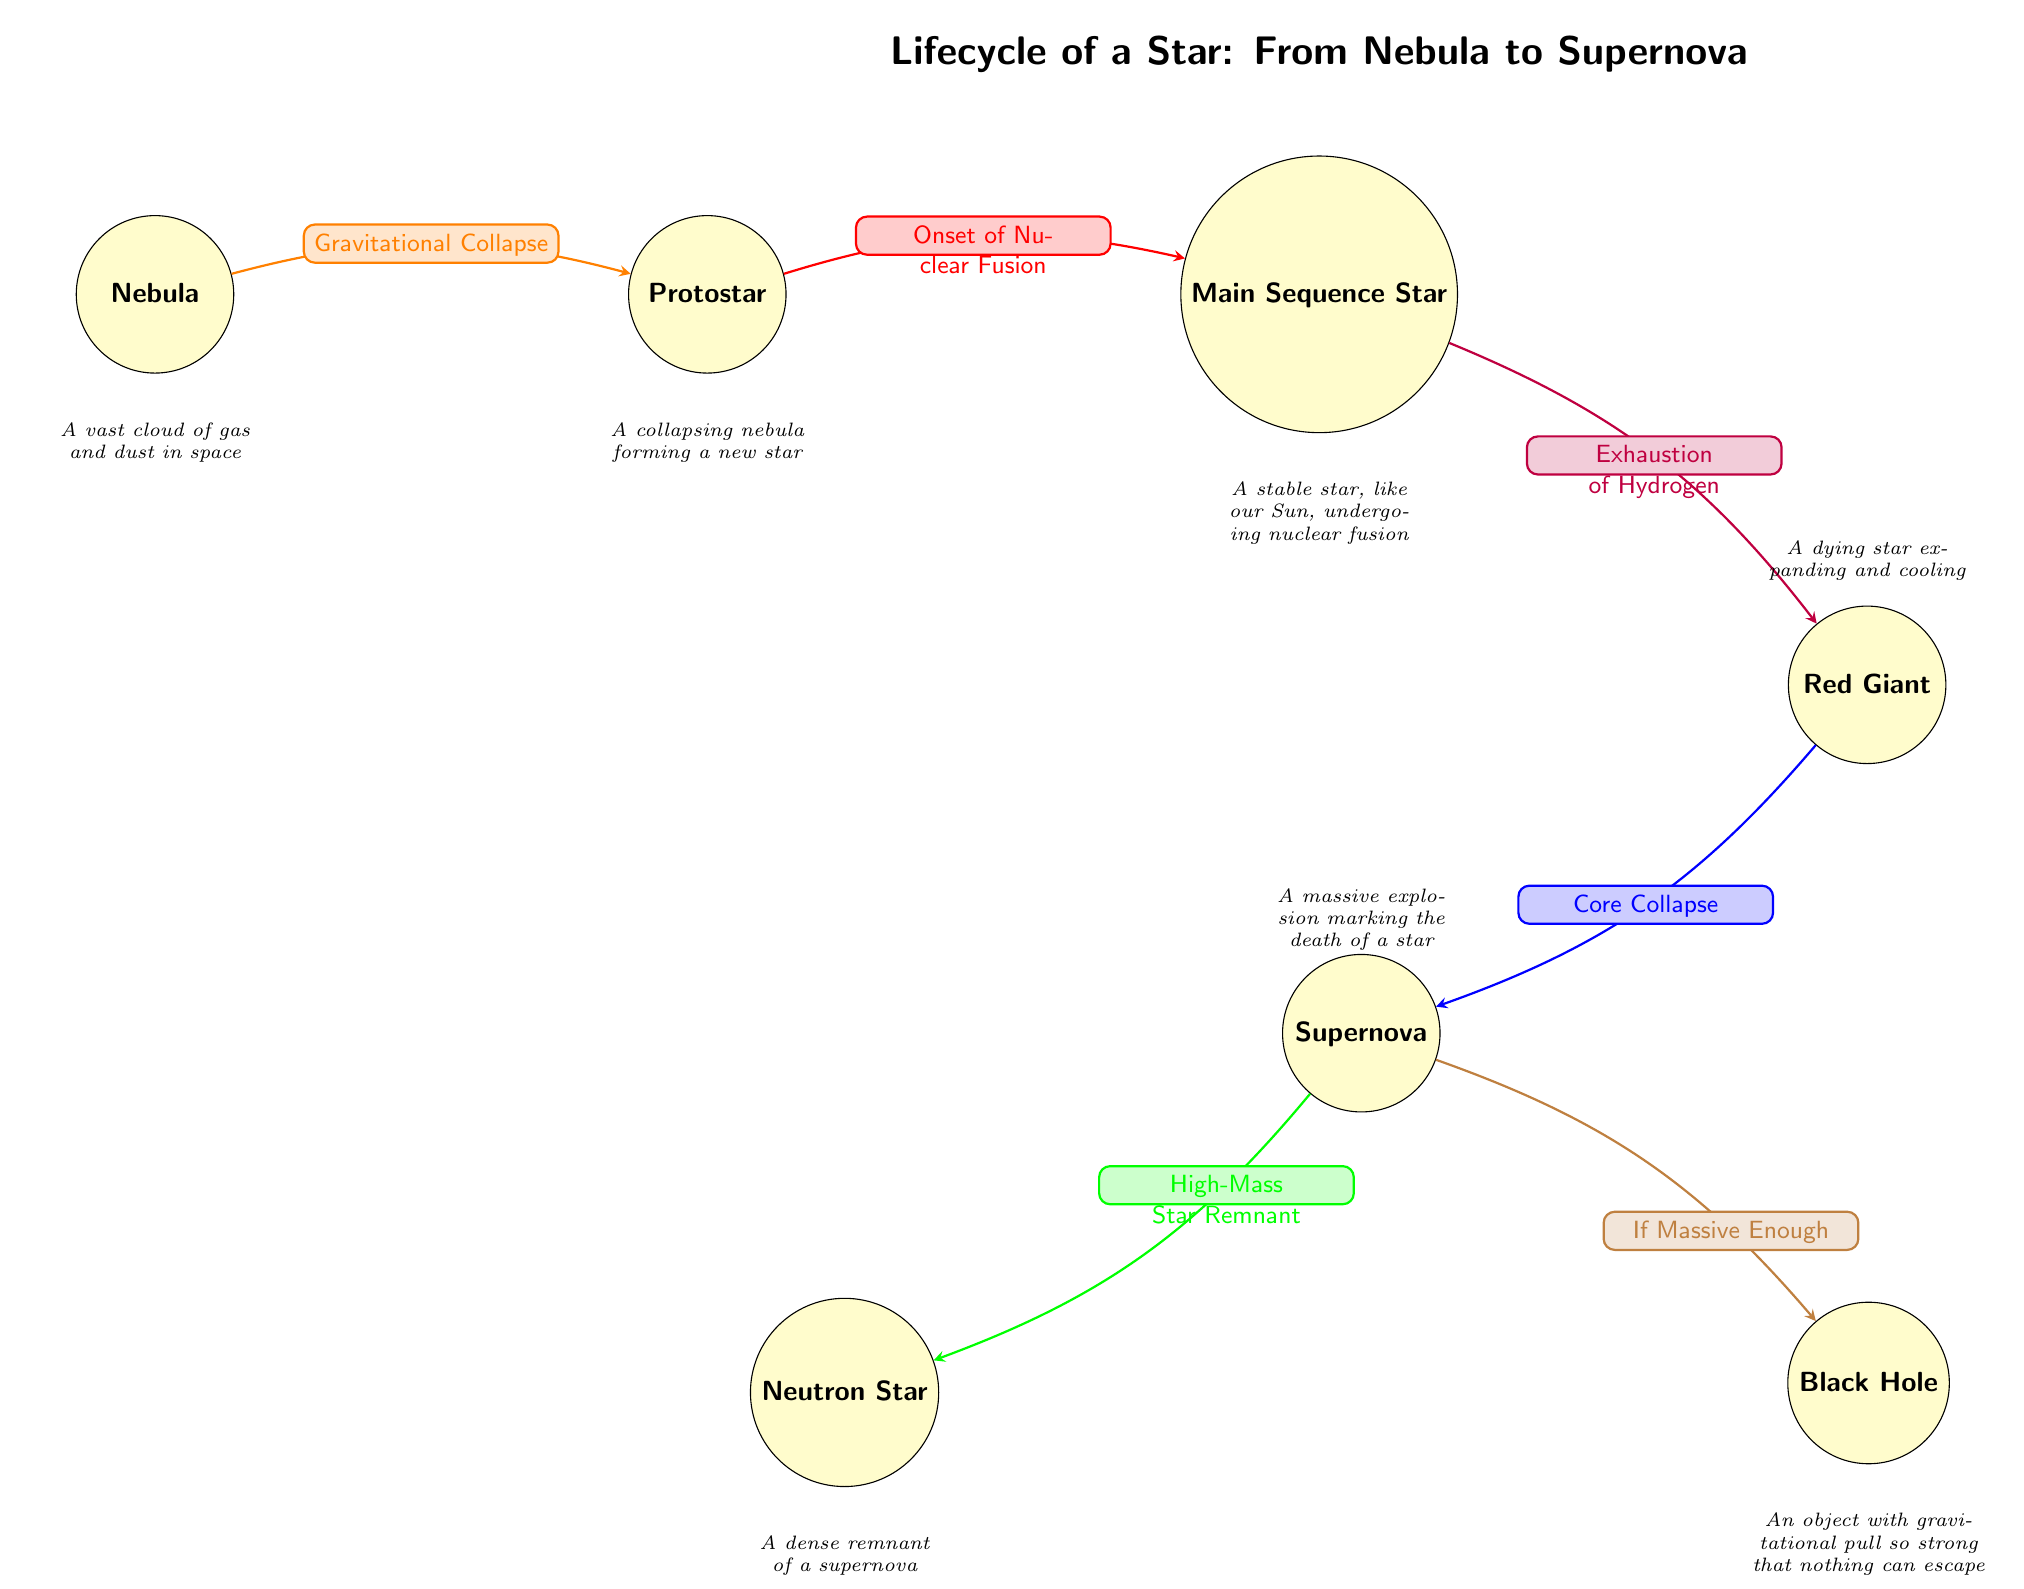What's the first stage of a star's lifecycle? The diagram shows the first node labeled "Nebula," which indicates the starting point of a star's lifecycle.
Answer: Nebula What happens after a protostar forms? The arrow from "Protostar" to "Main Sequence Star" indicates that the next stage in the lifecycle is the formation of a Main Sequence Star.
Answer: Main Sequence Star How many types of remnants can exist after a supernova? There are two possible outcomes after the "Supernova" stage, as indicated by the two arrows leading to "Neutron Star" and "Black Hole."
Answer: 2 What event leads to a red giant phase? The diagram shows that the transition from "Main Sequence Star" to "Red Giant" occurs due to the "Exhaustion of Hydrogen," which is stated on the arrow between these two nodes.
Answer: Exhaustion of Hydrogen What causes the star to go supernova? The transition from "Red Giant" to "Supernova" is marked by the event "Core Collapse," which is labeled on the arrow connecting the two nodes.
Answer: Core Collapse Which star type is stable during its lifecycle? The node labeled "Main Sequence Star" depicts a stable phase in a star's lifecycle as indicated in the diagram.
Answer: Main Sequence Star If a star is massive enough, what can it become after a supernova? The diagram indicates that if a star is massive enough after going supernova, it can become a "Black Hole," as per the labeled arrow leading from "Supernova."
Answer: Black Hole What describes the nebula in the diagram? The accompanying description below the "Nebula" node states that it is "A vast cloud of gas and dust in space," providing insight into this stage.
Answer: A vast cloud of gas and dust in space What is a neutron star? The description beneath the "Neutron Star" node defines it as "A dense remnant of a supernova," defining its nature in the lifecycle.
Answer: A dense remnant of a supernova 